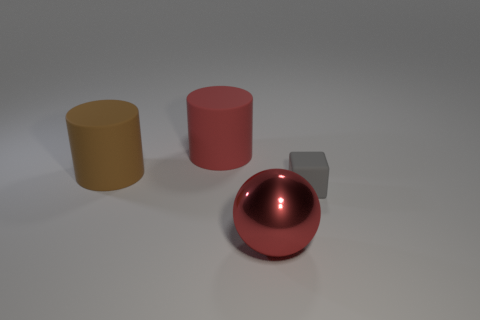Add 1 brown rubber objects. How many objects exist? 5 Subtract all spheres. How many objects are left? 3 Subtract all big red metal objects. Subtract all gray blocks. How many objects are left? 2 Add 4 tiny rubber blocks. How many tiny rubber blocks are left? 5 Add 4 small brown metal things. How many small brown metal things exist? 4 Subtract all red cylinders. How many cylinders are left? 1 Subtract 0 yellow blocks. How many objects are left? 4 Subtract all cyan balls. Subtract all brown cylinders. How many balls are left? 1 